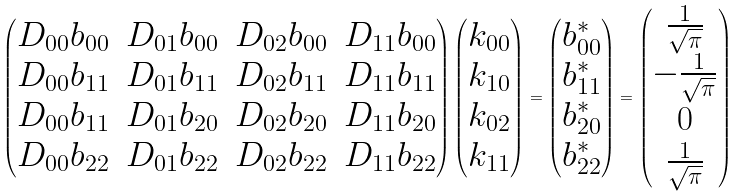Convert formula to latex. <formula><loc_0><loc_0><loc_500><loc_500>\begin{pmatrix} D _ { 0 0 } b _ { 0 0 } & D _ { 0 1 } b _ { 0 0 } & D _ { 0 2 } b _ { 0 0 } & D _ { 1 1 } b _ { 0 0 } \\ D _ { 0 0 } b _ { 1 1 } & D _ { 0 1 } b _ { 1 1 } & D _ { 0 2 } b _ { 1 1 } & D _ { 1 1 } b _ { 1 1 } \\ D _ { 0 0 } b _ { 1 1 } & D _ { 0 1 } b _ { 2 0 } & D _ { 0 2 } b _ { 2 0 } & D _ { 1 1 } b _ { 2 0 } \\ D _ { 0 0 } b _ { 2 2 } & D _ { 0 1 } b _ { 2 2 } & D _ { 0 2 } b _ { 2 2 } & D _ { 1 1 } b _ { 2 2 } \end{pmatrix} \begin{pmatrix} k _ { 0 0 } \\ k _ { 1 0 } \\ k _ { 0 2 } \\ k _ { 1 1 } \end{pmatrix} = \begin{pmatrix} b ^ { * } _ { 0 0 } \\ b ^ { * } _ { 1 1 } \\ b ^ { * } _ { 2 0 } \\ b ^ { * } _ { 2 2 } \end{pmatrix} = \begin{pmatrix} \frac { 1 } { \sqrt { \pi } } \\ - \frac { 1 } { \sqrt { \pi } } \\ 0 \\ \frac { 1 } { \sqrt { \pi } } \end{pmatrix}</formula> 